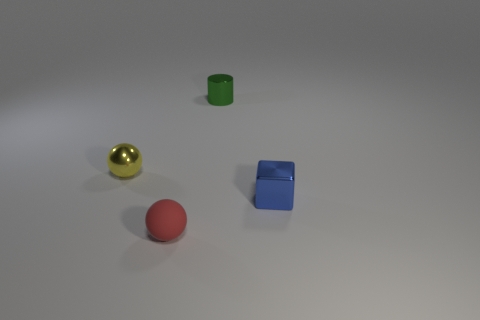There is a yellow ball; is its size the same as the block that is to the right of the rubber ball?
Your answer should be compact. Yes. Do the rubber object and the blue metallic block have the same size?
Your response must be concise. Yes. Is there a yellow block that has the same size as the yellow metallic object?
Give a very brief answer. No. There is a small thing on the right side of the tiny cylinder; what is it made of?
Your answer should be very brief. Metal. The cylinder that is made of the same material as the tiny cube is what color?
Offer a terse response. Green. What number of matte things are small cubes or small green cylinders?
Provide a succinct answer. 0. What shape is the blue shiny object that is the same size as the yellow thing?
Provide a short and direct response. Cube. How many objects are either things right of the red matte ball or metallic objects to the left of the tiny green cylinder?
Your answer should be compact. 3. What material is the red object that is the same size as the blue metal block?
Offer a very short reply. Rubber. How many other things are there of the same material as the tiny block?
Give a very brief answer. 2. 